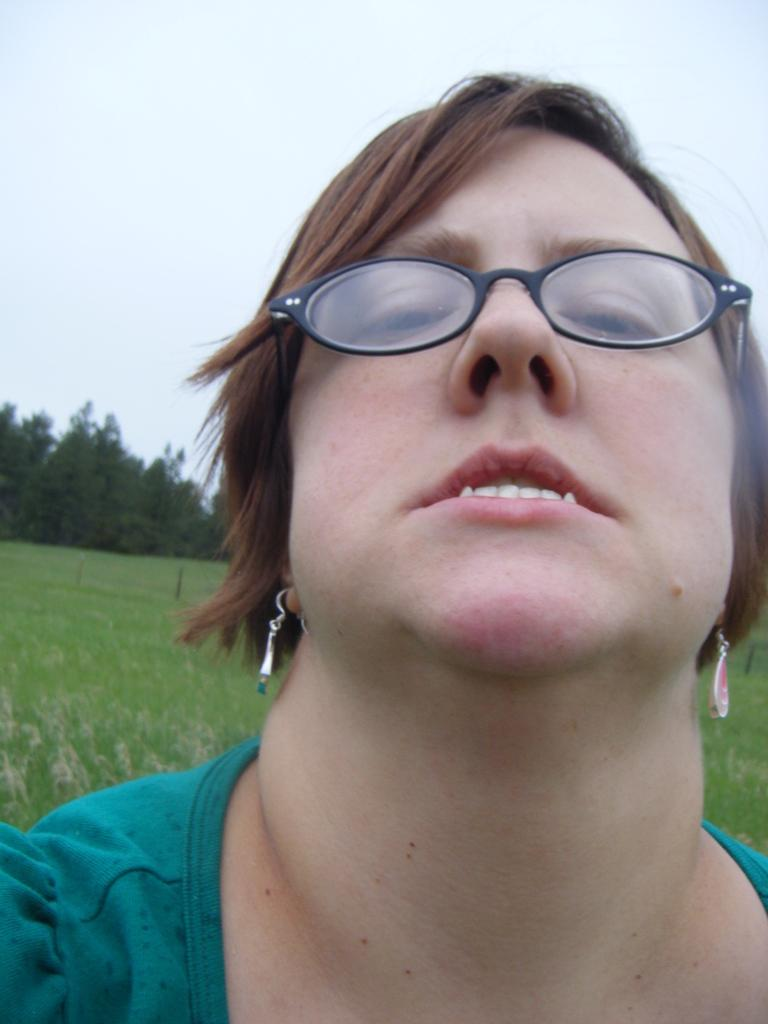Who is the main subject in the foreground of the image? There is a woman in the foreground of the image. What is the woman wearing on her face? The woman is wearing spectacles. What type of clothing is the woman wearing? The woman is wearing a dress. What type of jewelry is the woman wearing? The woman is wearing earrings. What can be seen in the background of the image? There is grass, trees, and the sky visible in the background of the image. What is the shortest route to the nearest soda fountain in the image? There is no soda fountain present in the image, so it is not possible to determine the shortest route to one. 